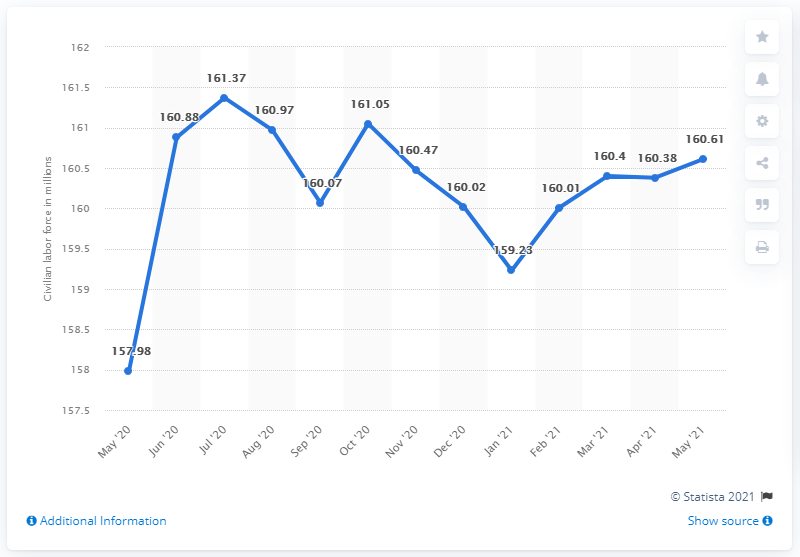Identify some key points in this picture. In May 2021, there were 160.61 million people in the civilian labor force in the United States. 